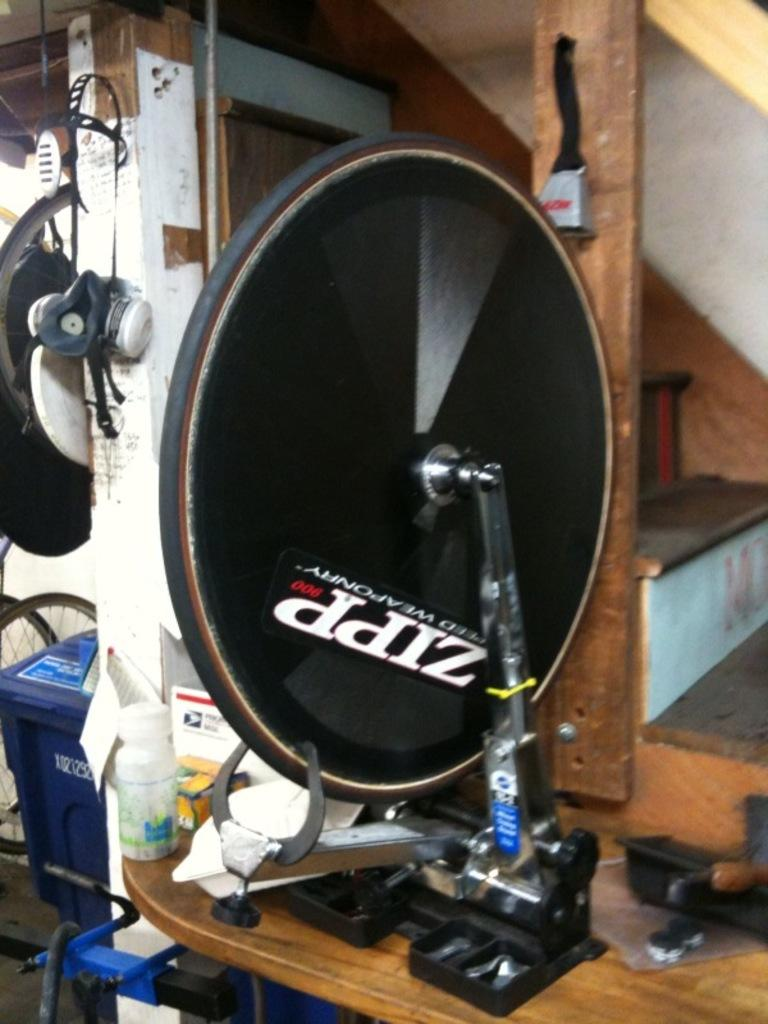What is the main object in the center of the image? There is a black color object in the center of the image. What is the object on the wooden surface? There is a bottle on a wooden surface. What can be seen in the background of the image? There is a trash bin in the background of the image. Are there any architectural features visible in the image? Yes, there are stairs visible in the image. What type of wool is being used to make the slippers in the image? There are no slippers present in the image, so it is not possible to determine the type of wool being used. 